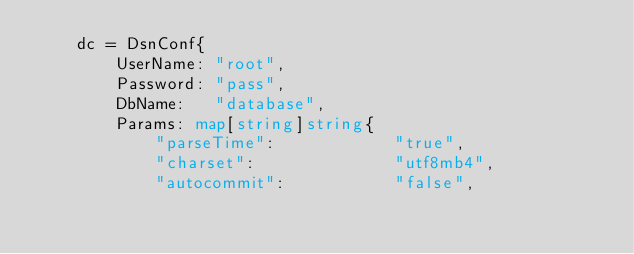<code> <loc_0><loc_0><loc_500><loc_500><_Go_>	dc = DsnConf{
		UserName: "root",
		Password: "pass",
		DbName:   "database",
		Params: map[string]string{
			"parseTime":            "true",
			"charset":              "utf8mb4",
			"autocommit":           "false",</code> 